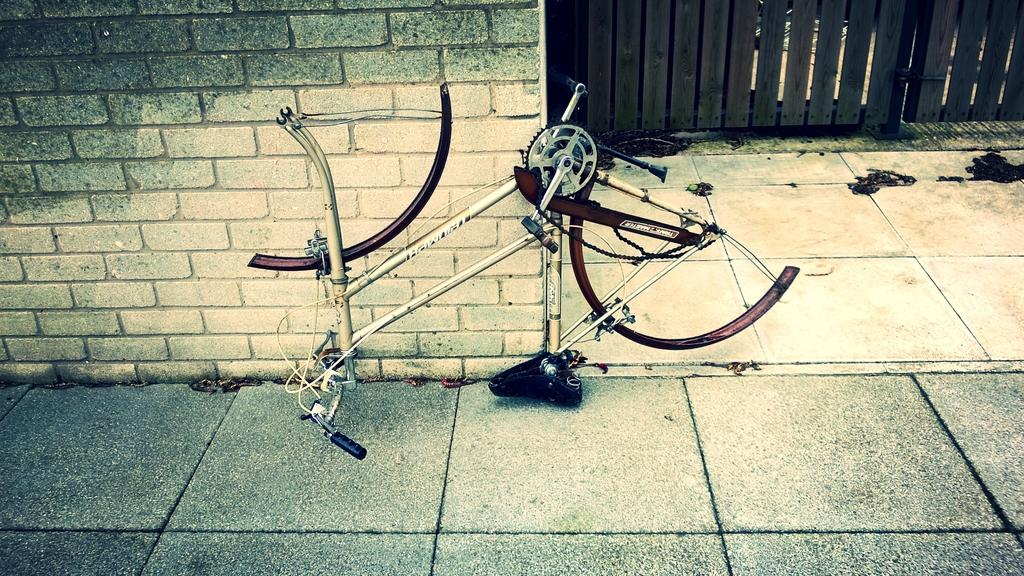What is the condition of the bicycle in the image? The bicycle in the image is damaged. Where is the damaged bicycle located in relation to other objects? The damaged bicycle is near a wall. What other structures can be seen in the image? There is a fence in the image. What type of oil is being used to lubricate the nut on the bicycle in the image? There is no oil or nut visible on the bicycle in the image; it is only described as being damaged. What type of glass is present in the image? There is no glass present in the image. 